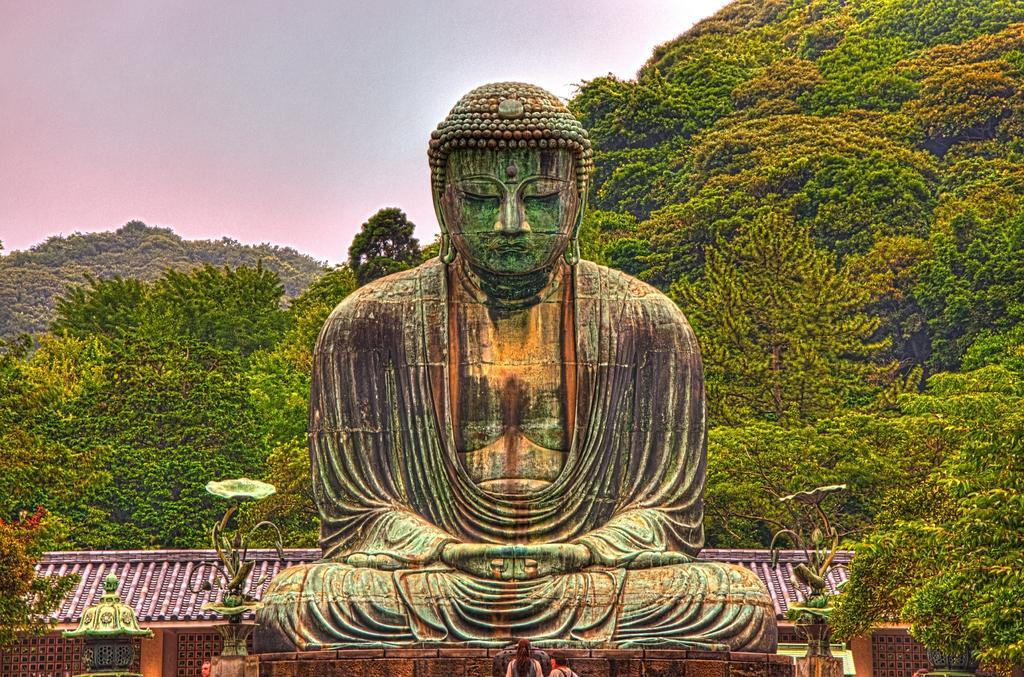What is the main subject in the center of the image? There is a Buddha statue in the middle of the image. What is the background of the image? There are green trees behind the Buddha statue. Where is the care located in the image? There is no care present in the image. What type of tub is visible in the image? There is no tub present in the image. 